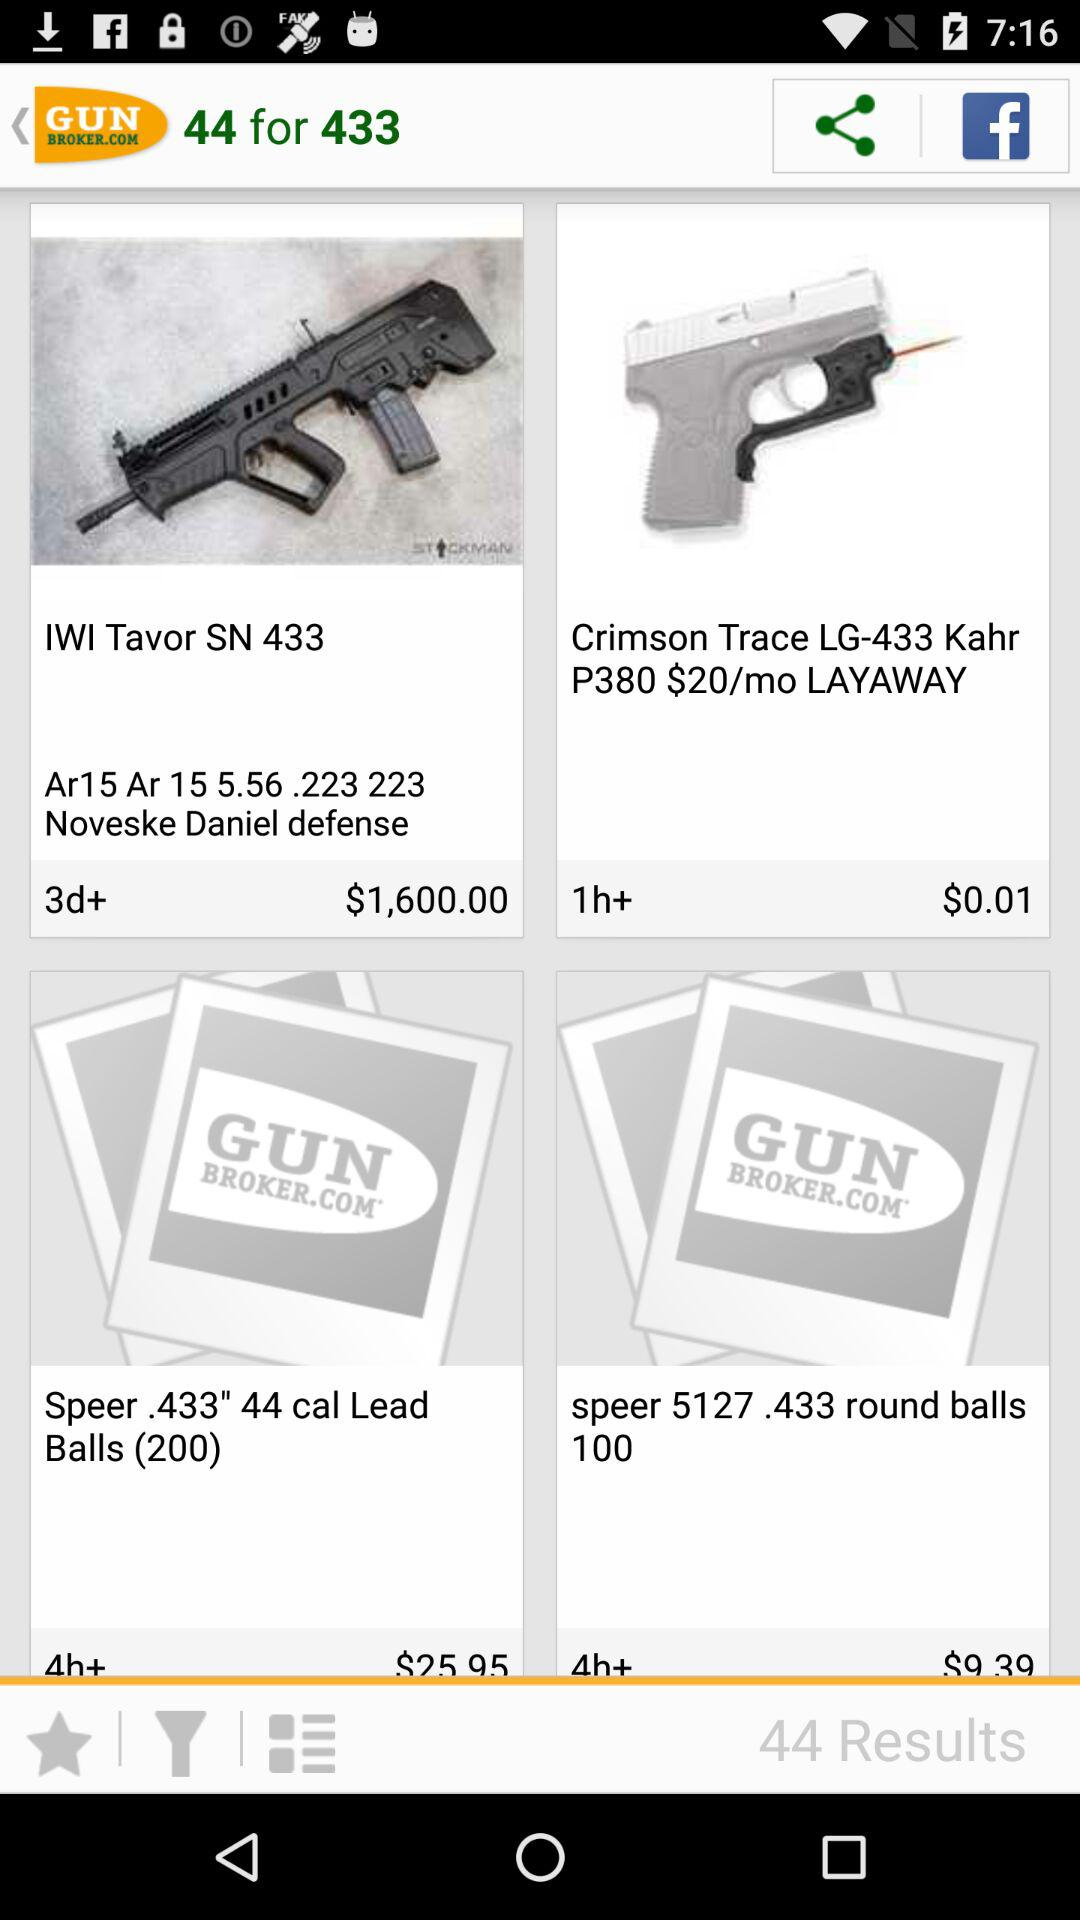How many items have a price less than $10.00?
Answer the question using a single word or phrase. 2 